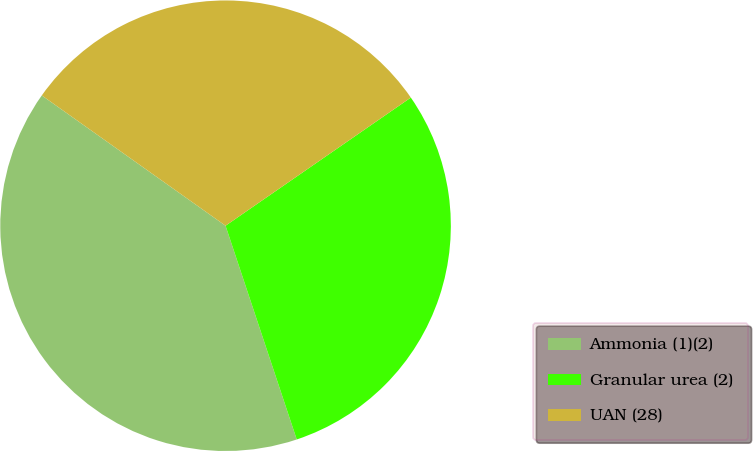Convert chart to OTSL. <chart><loc_0><loc_0><loc_500><loc_500><pie_chart><fcel>Ammonia (1)(2)<fcel>Granular urea (2)<fcel>UAN (28)<nl><fcel>39.93%<fcel>29.51%<fcel>30.55%<nl></chart> 